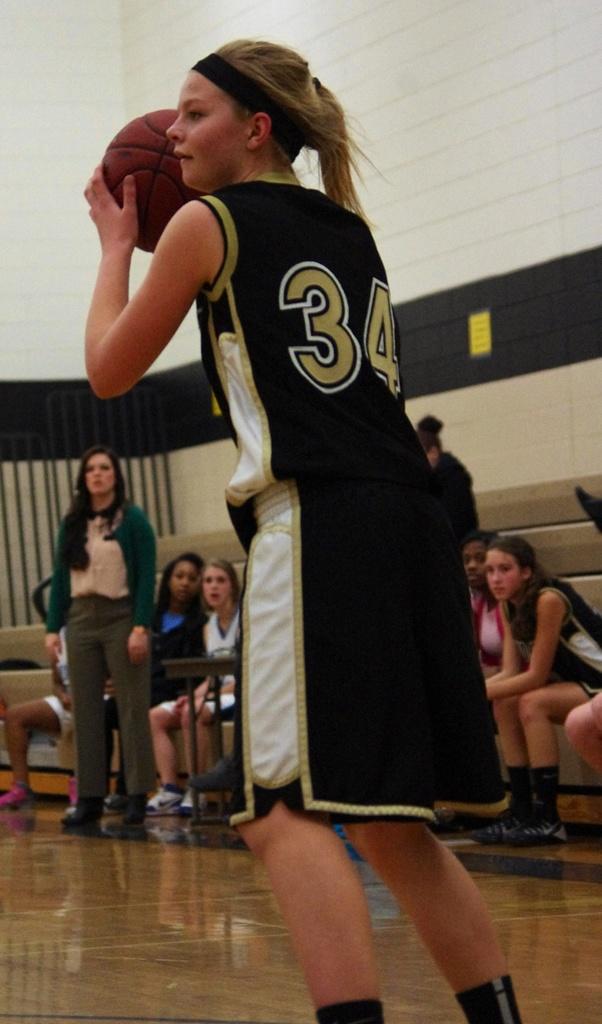What's this player's number?
Provide a short and direct response. 34. 